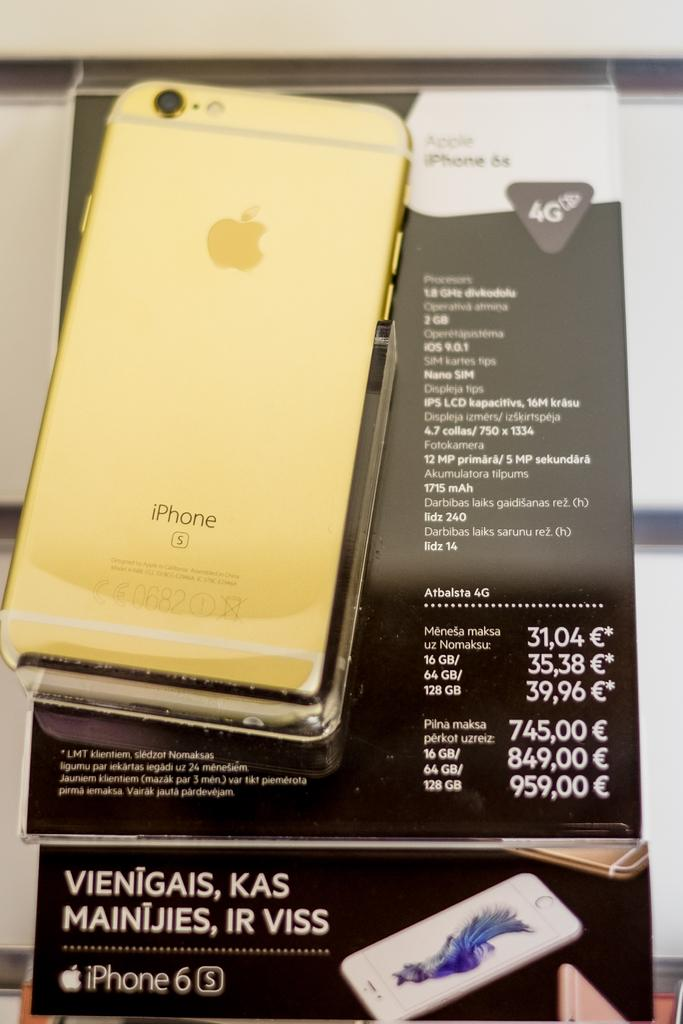<image>
Share a concise interpretation of the image provided. The back of the iPhone S with the number 0682 on the back. 